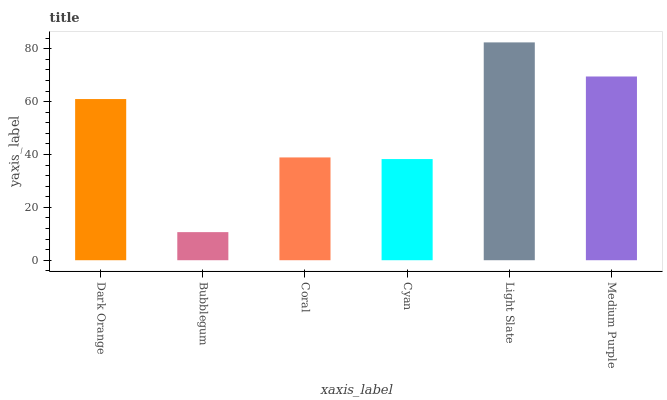Is Coral the minimum?
Answer yes or no. No. Is Coral the maximum?
Answer yes or no. No. Is Coral greater than Bubblegum?
Answer yes or no. Yes. Is Bubblegum less than Coral?
Answer yes or no. Yes. Is Bubblegum greater than Coral?
Answer yes or no. No. Is Coral less than Bubblegum?
Answer yes or no. No. Is Dark Orange the high median?
Answer yes or no. Yes. Is Coral the low median?
Answer yes or no. Yes. Is Light Slate the high median?
Answer yes or no. No. Is Light Slate the low median?
Answer yes or no. No. 